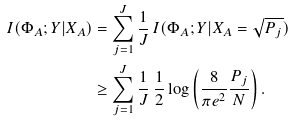<formula> <loc_0><loc_0><loc_500><loc_500>I ( \Phi _ { A } ; Y | X _ { A } ) & = \sum _ { j = 1 } ^ { J } \frac { 1 } { J } \, I ( \Phi _ { A } ; Y | X _ { A } = \sqrt { P _ { j } } ) \\ & \geq \sum _ { j = 1 } ^ { J } \frac { 1 } { J } \, \frac { 1 } { 2 } \log \left ( \frac { 8 } { \pi e ^ { 2 } } \frac { P _ { j } } { N } \right ) .</formula> 